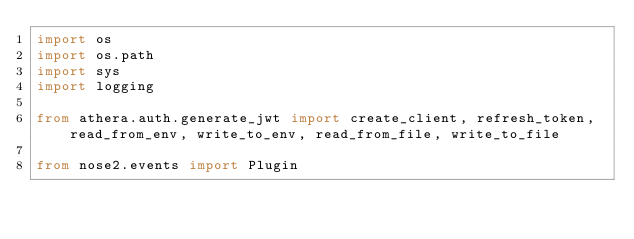Convert code to text. <code><loc_0><loc_0><loc_500><loc_500><_Python_>import os
import os.path
import sys
import logging

from athera.auth.generate_jwt import create_client, refresh_token, read_from_env, write_to_env, read_from_file, write_to_file

from nose2.events import Plugin
</code> 